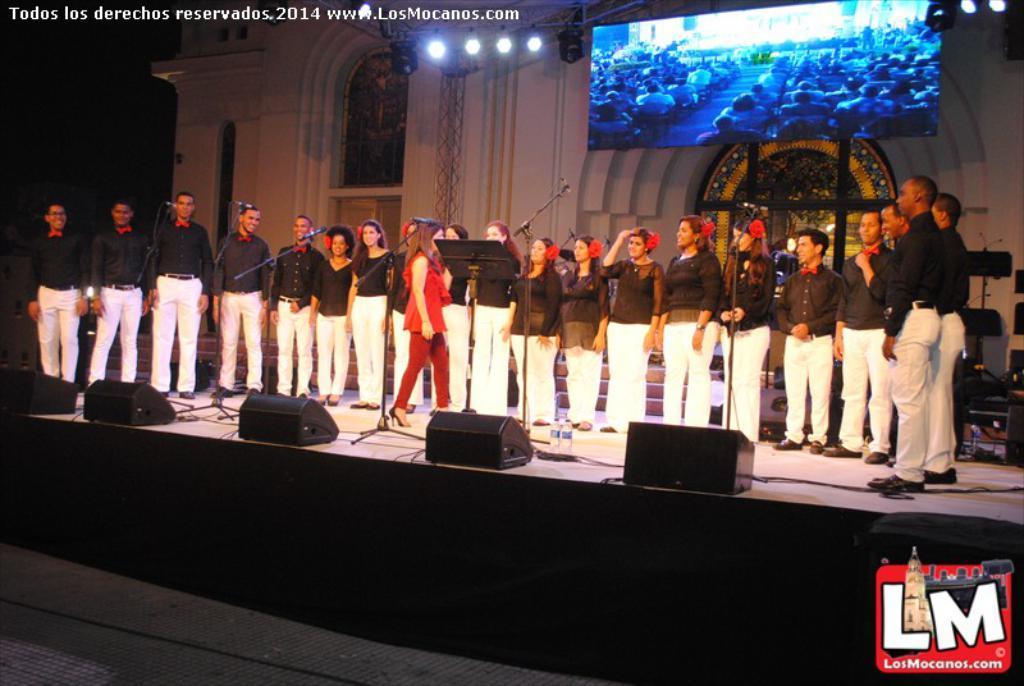Please provide a concise description of this image. In this image, we can see a group of people are on the stage. In the middle of the image, a woman walking. On this stage, we can see few boxes, stands with microphones. In the background, we can see wall, glass objects, few things, screen, lights, rods and dark view. At the bottom of the image, we can see the path. In the bottom right side of the image, there is a logo. In the top left side of the image, we can see the watermark. 